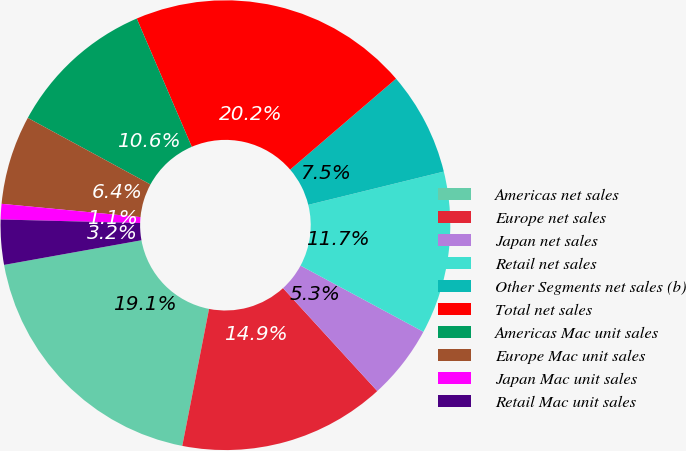Convert chart to OTSL. <chart><loc_0><loc_0><loc_500><loc_500><pie_chart><fcel>Americas net sales<fcel>Europe net sales<fcel>Japan net sales<fcel>Retail net sales<fcel>Other Segments net sales (b)<fcel>Total net sales<fcel>Americas Mac unit sales<fcel>Europe Mac unit sales<fcel>Japan Mac unit sales<fcel>Retail Mac unit sales<nl><fcel>19.1%<fcel>14.87%<fcel>5.34%<fcel>11.69%<fcel>7.46%<fcel>20.16%<fcel>10.63%<fcel>6.4%<fcel>1.11%<fcel>3.23%<nl></chart> 